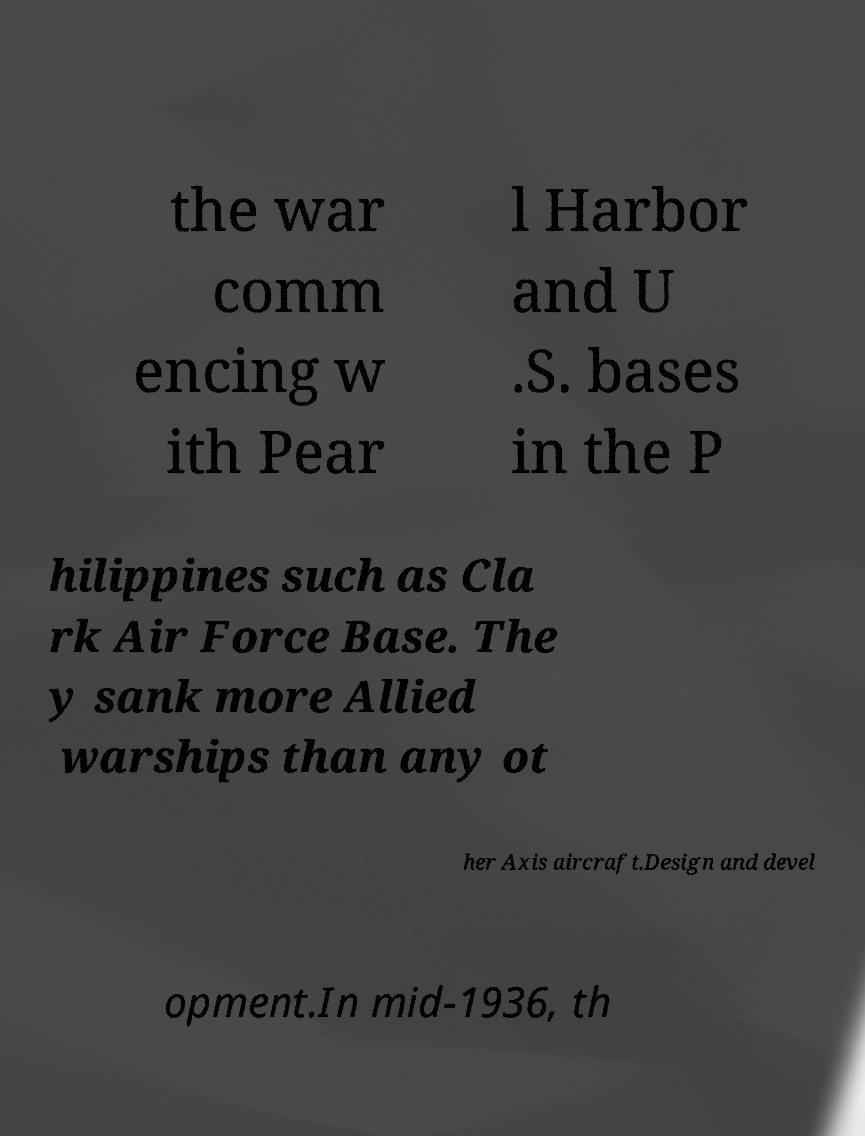I need the written content from this picture converted into text. Can you do that? the war comm encing w ith Pear l Harbor and U .S. bases in the P hilippines such as Cla rk Air Force Base. The y sank more Allied warships than any ot her Axis aircraft.Design and devel opment.In mid-1936, th 